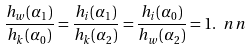<formula> <loc_0><loc_0><loc_500><loc_500>\frac { h _ { w } ( \alpha _ { 1 } ) } { h _ { k } ( \alpha _ { 0 } ) } = \frac { h _ { i } ( \alpha _ { 1 } ) } { h _ { k } ( \alpha _ { 2 } ) } = \frac { h _ { i } ( \alpha _ { 0 } ) } { h _ { w } ( \alpha _ { 2 } ) } = 1 . \ n n</formula> 